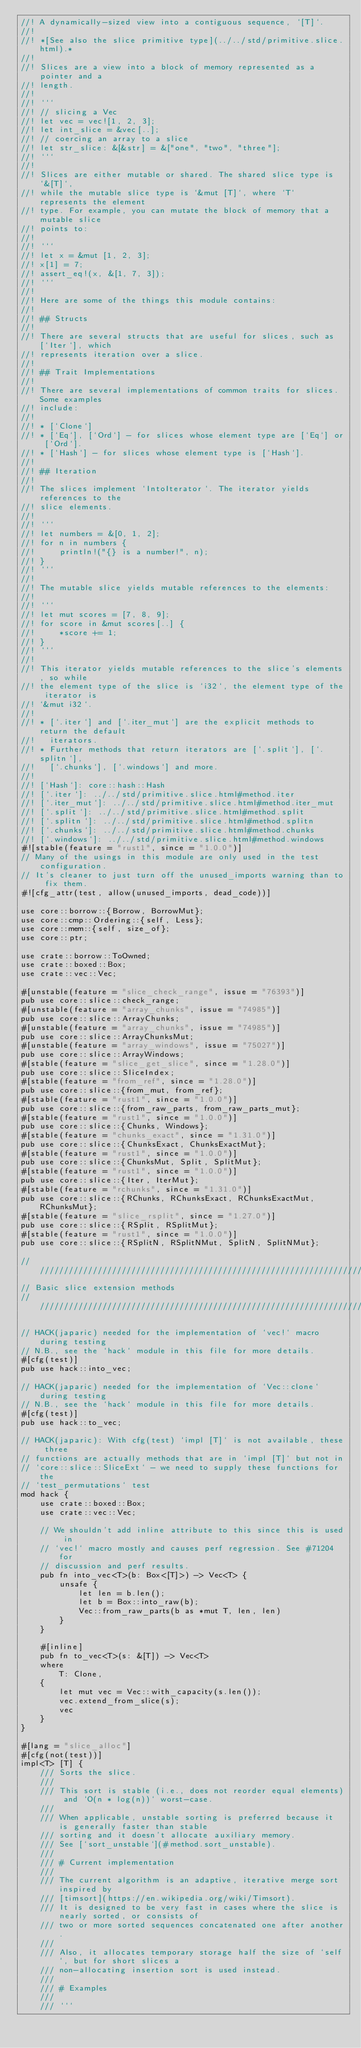Convert code to text. <code><loc_0><loc_0><loc_500><loc_500><_Rust_>//! A dynamically-sized view into a contiguous sequence, `[T]`.
//!
//! *[See also the slice primitive type](../../std/primitive.slice.html).*
//!
//! Slices are a view into a block of memory represented as a pointer and a
//! length.
//!
//! ```
//! // slicing a Vec
//! let vec = vec![1, 2, 3];
//! let int_slice = &vec[..];
//! // coercing an array to a slice
//! let str_slice: &[&str] = &["one", "two", "three"];
//! ```
//!
//! Slices are either mutable or shared. The shared slice type is `&[T]`,
//! while the mutable slice type is `&mut [T]`, where `T` represents the element
//! type. For example, you can mutate the block of memory that a mutable slice
//! points to:
//!
//! ```
//! let x = &mut [1, 2, 3];
//! x[1] = 7;
//! assert_eq!(x, &[1, 7, 3]);
//! ```
//!
//! Here are some of the things this module contains:
//!
//! ## Structs
//!
//! There are several structs that are useful for slices, such as [`Iter`], which
//! represents iteration over a slice.
//!
//! ## Trait Implementations
//!
//! There are several implementations of common traits for slices. Some examples
//! include:
//!
//! * [`Clone`]
//! * [`Eq`], [`Ord`] - for slices whose element type are [`Eq`] or [`Ord`].
//! * [`Hash`] - for slices whose element type is [`Hash`].
//!
//! ## Iteration
//!
//! The slices implement `IntoIterator`. The iterator yields references to the
//! slice elements.
//!
//! ```
//! let numbers = &[0, 1, 2];
//! for n in numbers {
//!     println!("{} is a number!", n);
//! }
//! ```
//!
//! The mutable slice yields mutable references to the elements:
//!
//! ```
//! let mut scores = [7, 8, 9];
//! for score in &mut scores[..] {
//!     *score += 1;
//! }
//! ```
//!
//! This iterator yields mutable references to the slice's elements, so while
//! the element type of the slice is `i32`, the element type of the iterator is
//! `&mut i32`.
//!
//! * [`.iter`] and [`.iter_mut`] are the explicit methods to return the default
//!   iterators.
//! * Further methods that return iterators are [`.split`], [`.splitn`],
//!   [`.chunks`], [`.windows`] and more.
//!
//! [`Hash`]: core::hash::Hash
//! [`.iter`]: ../../std/primitive.slice.html#method.iter
//! [`.iter_mut`]: ../../std/primitive.slice.html#method.iter_mut
//! [`.split`]: ../../std/primitive.slice.html#method.split
//! [`.splitn`]: ../../std/primitive.slice.html#method.splitn
//! [`.chunks`]: ../../std/primitive.slice.html#method.chunks
//! [`.windows`]: ../../std/primitive.slice.html#method.windows
#![stable(feature = "rust1", since = "1.0.0")]
// Many of the usings in this module are only used in the test configuration.
// It's cleaner to just turn off the unused_imports warning than to fix them.
#![cfg_attr(test, allow(unused_imports, dead_code))]

use core::borrow::{Borrow, BorrowMut};
use core::cmp::Ordering::{self, Less};
use core::mem::{self, size_of};
use core::ptr;

use crate::borrow::ToOwned;
use crate::boxed::Box;
use crate::vec::Vec;

#[unstable(feature = "slice_check_range", issue = "76393")]
pub use core::slice::check_range;
#[unstable(feature = "array_chunks", issue = "74985")]
pub use core::slice::ArrayChunks;
#[unstable(feature = "array_chunks", issue = "74985")]
pub use core::slice::ArrayChunksMut;
#[unstable(feature = "array_windows", issue = "75027")]
pub use core::slice::ArrayWindows;
#[stable(feature = "slice_get_slice", since = "1.28.0")]
pub use core::slice::SliceIndex;
#[stable(feature = "from_ref", since = "1.28.0")]
pub use core::slice::{from_mut, from_ref};
#[stable(feature = "rust1", since = "1.0.0")]
pub use core::slice::{from_raw_parts, from_raw_parts_mut};
#[stable(feature = "rust1", since = "1.0.0")]
pub use core::slice::{Chunks, Windows};
#[stable(feature = "chunks_exact", since = "1.31.0")]
pub use core::slice::{ChunksExact, ChunksExactMut};
#[stable(feature = "rust1", since = "1.0.0")]
pub use core::slice::{ChunksMut, Split, SplitMut};
#[stable(feature = "rust1", since = "1.0.0")]
pub use core::slice::{Iter, IterMut};
#[stable(feature = "rchunks", since = "1.31.0")]
pub use core::slice::{RChunks, RChunksExact, RChunksExactMut, RChunksMut};
#[stable(feature = "slice_rsplit", since = "1.27.0")]
pub use core::slice::{RSplit, RSplitMut};
#[stable(feature = "rust1", since = "1.0.0")]
pub use core::slice::{RSplitN, RSplitNMut, SplitN, SplitNMut};

////////////////////////////////////////////////////////////////////////////////
// Basic slice extension methods
////////////////////////////////////////////////////////////////////////////////

// HACK(japaric) needed for the implementation of `vec!` macro during testing
// N.B., see the `hack` module in this file for more details.
#[cfg(test)]
pub use hack::into_vec;

// HACK(japaric) needed for the implementation of `Vec::clone` during testing
// N.B., see the `hack` module in this file for more details.
#[cfg(test)]
pub use hack::to_vec;

// HACK(japaric): With cfg(test) `impl [T]` is not available, these three
// functions are actually methods that are in `impl [T]` but not in
// `core::slice::SliceExt` - we need to supply these functions for the
// `test_permutations` test
mod hack {
    use crate::boxed::Box;
    use crate::vec::Vec;

    // We shouldn't add inline attribute to this since this is used in
    // `vec!` macro mostly and causes perf regression. See #71204 for
    // discussion and perf results.
    pub fn into_vec<T>(b: Box<[T]>) -> Vec<T> {
        unsafe {
            let len = b.len();
            let b = Box::into_raw(b);
            Vec::from_raw_parts(b as *mut T, len, len)
        }
    }

    #[inline]
    pub fn to_vec<T>(s: &[T]) -> Vec<T>
    where
        T: Clone,
    {
        let mut vec = Vec::with_capacity(s.len());
        vec.extend_from_slice(s);
        vec
    }
}

#[lang = "slice_alloc"]
#[cfg(not(test))]
impl<T> [T] {
    /// Sorts the slice.
    ///
    /// This sort is stable (i.e., does not reorder equal elements) and `O(n * log(n))` worst-case.
    ///
    /// When applicable, unstable sorting is preferred because it is generally faster than stable
    /// sorting and it doesn't allocate auxiliary memory.
    /// See [`sort_unstable`](#method.sort_unstable).
    ///
    /// # Current implementation
    ///
    /// The current algorithm is an adaptive, iterative merge sort inspired by
    /// [timsort](https://en.wikipedia.org/wiki/Timsort).
    /// It is designed to be very fast in cases where the slice is nearly sorted, or consists of
    /// two or more sorted sequences concatenated one after another.
    ///
    /// Also, it allocates temporary storage half the size of `self`, but for short slices a
    /// non-allocating insertion sort is used instead.
    ///
    /// # Examples
    ///
    /// ```</code> 